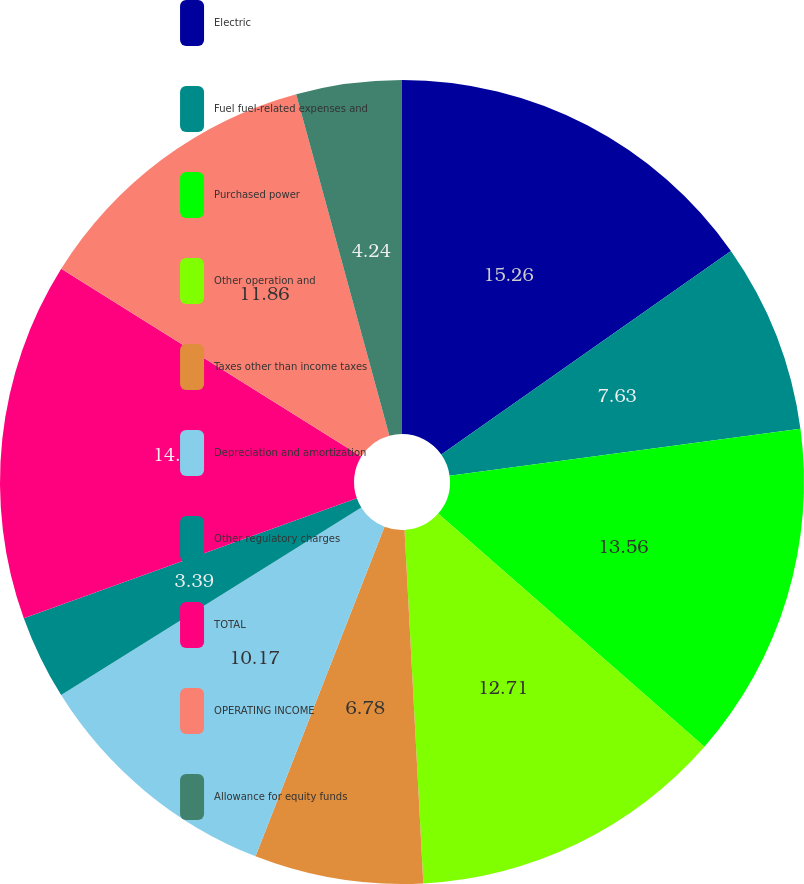Convert chart. <chart><loc_0><loc_0><loc_500><loc_500><pie_chart><fcel>Electric<fcel>Fuel fuel-related expenses and<fcel>Purchased power<fcel>Other operation and<fcel>Taxes other than income taxes<fcel>Depreciation and amortization<fcel>Other regulatory charges<fcel>TOTAL<fcel>OPERATING INCOME<fcel>Allowance for equity funds<nl><fcel>15.25%<fcel>7.63%<fcel>13.56%<fcel>12.71%<fcel>6.78%<fcel>10.17%<fcel>3.39%<fcel>14.4%<fcel>11.86%<fcel>4.24%<nl></chart> 